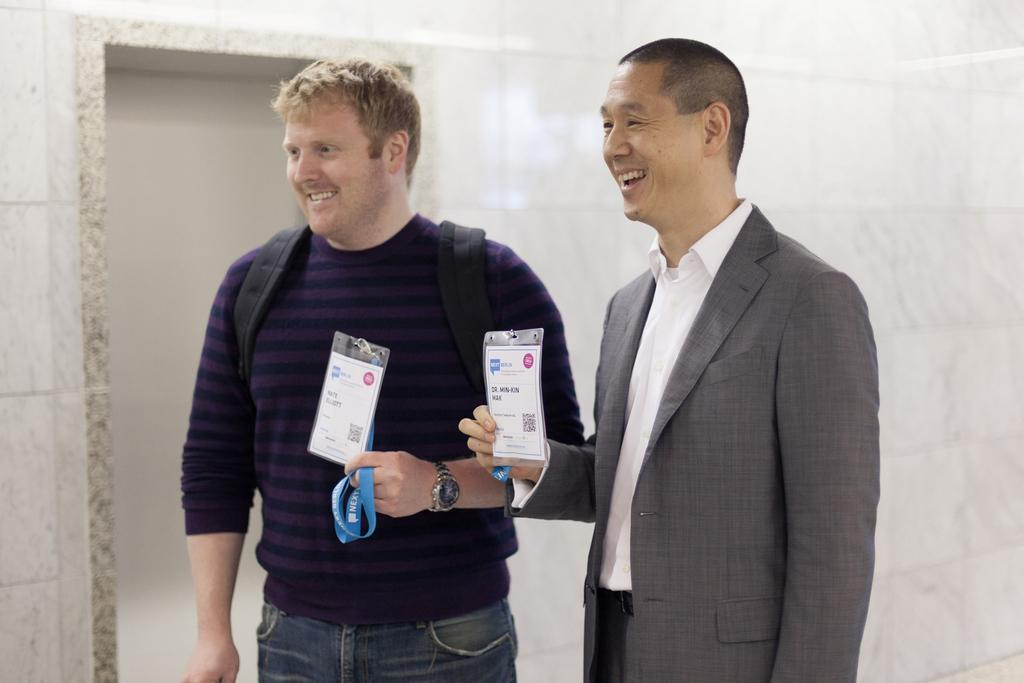How many people are in the image? There are two men in the image. What are the men doing in the image? The men are standing and showing their ID cards. What is the facial expression of the men in the image? The men are smiling in the image. Can you hear the men sneezing in the image? There is no sound in the image, so it is not possible to hear the men sneezing. 